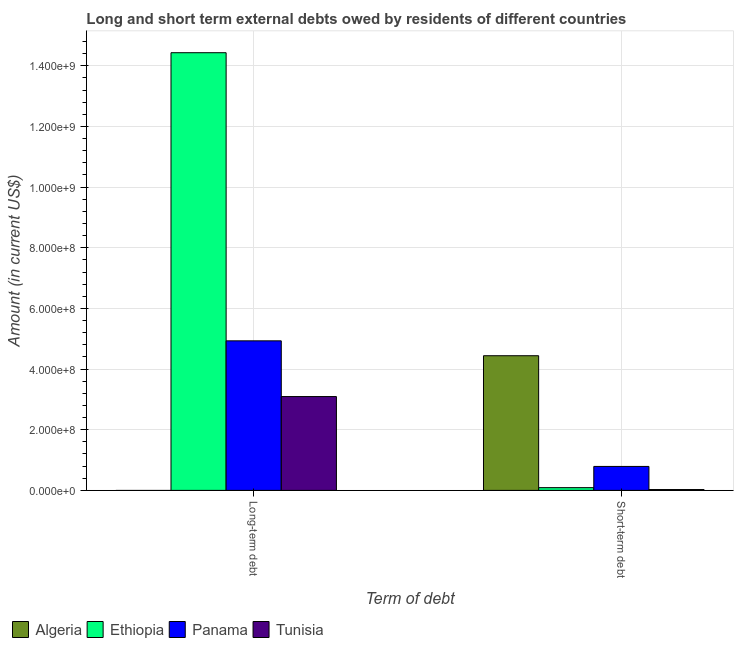How many bars are there on the 2nd tick from the left?
Keep it short and to the point. 4. How many bars are there on the 2nd tick from the right?
Your answer should be very brief. 3. What is the label of the 1st group of bars from the left?
Your response must be concise. Long-term debt. What is the long-term debts owed by residents in Ethiopia?
Your answer should be compact. 1.44e+09. Across all countries, what is the maximum short-term debts owed by residents?
Keep it short and to the point. 4.44e+08. Across all countries, what is the minimum long-term debts owed by residents?
Give a very brief answer. 0. In which country was the short-term debts owed by residents maximum?
Offer a very short reply. Algeria. What is the total long-term debts owed by residents in the graph?
Provide a short and direct response. 2.25e+09. What is the difference between the long-term debts owed by residents in Ethiopia and that in Panama?
Provide a short and direct response. 9.50e+08. What is the difference between the short-term debts owed by residents in Panama and the long-term debts owed by residents in Ethiopia?
Keep it short and to the point. -1.36e+09. What is the average short-term debts owed by residents per country?
Ensure brevity in your answer.  1.34e+08. What is the difference between the long-term debts owed by residents and short-term debts owed by residents in Ethiopia?
Keep it short and to the point. 1.43e+09. In how many countries, is the long-term debts owed by residents greater than 1000000000 US$?
Keep it short and to the point. 1. What is the ratio of the short-term debts owed by residents in Ethiopia to that in Tunisia?
Your answer should be compact. 3.21. Is the short-term debts owed by residents in Algeria less than that in Tunisia?
Your answer should be compact. No. In how many countries, is the short-term debts owed by residents greater than the average short-term debts owed by residents taken over all countries?
Your response must be concise. 1. How many bars are there?
Keep it short and to the point. 7. How many countries are there in the graph?
Give a very brief answer. 4. What is the difference between two consecutive major ticks on the Y-axis?
Offer a very short reply. 2.00e+08. Are the values on the major ticks of Y-axis written in scientific E-notation?
Provide a short and direct response. Yes. Does the graph contain grids?
Your response must be concise. Yes. Where does the legend appear in the graph?
Ensure brevity in your answer.  Bottom left. How many legend labels are there?
Ensure brevity in your answer.  4. What is the title of the graph?
Provide a short and direct response. Long and short term external debts owed by residents of different countries. Does "Saudi Arabia" appear as one of the legend labels in the graph?
Keep it short and to the point. No. What is the label or title of the X-axis?
Offer a very short reply. Term of debt. What is the Amount (in current US$) in Algeria in Long-term debt?
Give a very brief answer. 0. What is the Amount (in current US$) in Ethiopia in Long-term debt?
Keep it short and to the point. 1.44e+09. What is the Amount (in current US$) in Panama in Long-term debt?
Your answer should be compact. 4.93e+08. What is the Amount (in current US$) of Tunisia in Long-term debt?
Keep it short and to the point. 3.09e+08. What is the Amount (in current US$) in Algeria in Short-term debt?
Ensure brevity in your answer.  4.44e+08. What is the Amount (in current US$) of Ethiopia in Short-term debt?
Keep it short and to the point. 9.00e+06. What is the Amount (in current US$) of Panama in Short-term debt?
Provide a succinct answer. 7.90e+07. What is the Amount (in current US$) of Tunisia in Short-term debt?
Offer a terse response. 2.80e+06. Across all Term of debt, what is the maximum Amount (in current US$) of Algeria?
Your response must be concise. 4.44e+08. Across all Term of debt, what is the maximum Amount (in current US$) of Ethiopia?
Offer a very short reply. 1.44e+09. Across all Term of debt, what is the maximum Amount (in current US$) in Panama?
Offer a very short reply. 4.93e+08. Across all Term of debt, what is the maximum Amount (in current US$) of Tunisia?
Your answer should be compact. 3.09e+08. Across all Term of debt, what is the minimum Amount (in current US$) in Ethiopia?
Provide a short and direct response. 9.00e+06. Across all Term of debt, what is the minimum Amount (in current US$) of Panama?
Your response must be concise. 7.90e+07. Across all Term of debt, what is the minimum Amount (in current US$) in Tunisia?
Give a very brief answer. 2.80e+06. What is the total Amount (in current US$) of Algeria in the graph?
Ensure brevity in your answer.  4.44e+08. What is the total Amount (in current US$) in Ethiopia in the graph?
Offer a terse response. 1.45e+09. What is the total Amount (in current US$) in Panama in the graph?
Make the answer very short. 5.72e+08. What is the total Amount (in current US$) in Tunisia in the graph?
Give a very brief answer. 3.12e+08. What is the difference between the Amount (in current US$) in Ethiopia in Long-term debt and that in Short-term debt?
Ensure brevity in your answer.  1.43e+09. What is the difference between the Amount (in current US$) in Panama in Long-term debt and that in Short-term debt?
Offer a very short reply. 4.14e+08. What is the difference between the Amount (in current US$) in Tunisia in Long-term debt and that in Short-term debt?
Keep it short and to the point. 3.07e+08. What is the difference between the Amount (in current US$) of Ethiopia in Long-term debt and the Amount (in current US$) of Panama in Short-term debt?
Your answer should be compact. 1.36e+09. What is the difference between the Amount (in current US$) of Ethiopia in Long-term debt and the Amount (in current US$) of Tunisia in Short-term debt?
Your response must be concise. 1.44e+09. What is the difference between the Amount (in current US$) of Panama in Long-term debt and the Amount (in current US$) of Tunisia in Short-term debt?
Ensure brevity in your answer.  4.90e+08. What is the average Amount (in current US$) in Algeria per Term of debt?
Your answer should be compact. 2.22e+08. What is the average Amount (in current US$) in Ethiopia per Term of debt?
Offer a terse response. 7.26e+08. What is the average Amount (in current US$) in Panama per Term of debt?
Offer a terse response. 2.86e+08. What is the average Amount (in current US$) in Tunisia per Term of debt?
Provide a succinct answer. 1.56e+08. What is the difference between the Amount (in current US$) in Ethiopia and Amount (in current US$) in Panama in Long-term debt?
Your answer should be compact. 9.50e+08. What is the difference between the Amount (in current US$) in Ethiopia and Amount (in current US$) in Tunisia in Long-term debt?
Give a very brief answer. 1.13e+09. What is the difference between the Amount (in current US$) of Panama and Amount (in current US$) of Tunisia in Long-term debt?
Offer a terse response. 1.84e+08. What is the difference between the Amount (in current US$) of Algeria and Amount (in current US$) of Ethiopia in Short-term debt?
Offer a very short reply. 4.35e+08. What is the difference between the Amount (in current US$) of Algeria and Amount (in current US$) of Panama in Short-term debt?
Keep it short and to the point. 3.65e+08. What is the difference between the Amount (in current US$) in Algeria and Amount (in current US$) in Tunisia in Short-term debt?
Your answer should be very brief. 4.41e+08. What is the difference between the Amount (in current US$) in Ethiopia and Amount (in current US$) in Panama in Short-term debt?
Make the answer very short. -7.00e+07. What is the difference between the Amount (in current US$) in Ethiopia and Amount (in current US$) in Tunisia in Short-term debt?
Your answer should be compact. 6.20e+06. What is the difference between the Amount (in current US$) of Panama and Amount (in current US$) of Tunisia in Short-term debt?
Ensure brevity in your answer.  7.62e+07. What is the ratio of the Amount (in current US$) in Ethiopia in Long-term debt to that in Short-term debt?
Offer a terse response. 160.36. What is the ratio of the Amount (in current US$) in Panama in Long-term debt to that in Short-term debt?
Provide a succinct answer. 6.24. What is the ratio of the Amount (in current US$) in Tunisia in Long-term debt to that in Short-term debt?
Your response must be concise. 110.49. What is the difference between the highest and the second highest Amount (in current US$) of Ethiopia?
Give a very brief answer. 1.43e+09. What is the difference between the highest and the second highest Amount (in current US$) of Panama?
Your answer should be very brief. 4.14e+08. What is the difference between the highest and the second highest Amount (in current US$) in Tunisia?
Keep it short and to the point. 3.07e+08. What is the difference between the highest and the lowest Amount (in current US$) in Algeria?
Ensure brevity in your answer.  4.44e+08. What is the difference between the highest and the lowest Amount (in current US$) of Ethiopia?
Provide a succinct answer. 1.43e+09. What is the difference between the highest and the lowest Amount (in current US$) of Panama?
Your response must be concise. 4.14e+08. What is the difference between the highest and the lowest Amount (in current US$) of Tunisia?
Make the answer very short. 3.07e+08. 